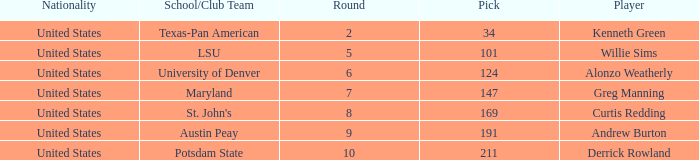What is the average Pick when the round was less than 6 for kenneth green? 34.0. 